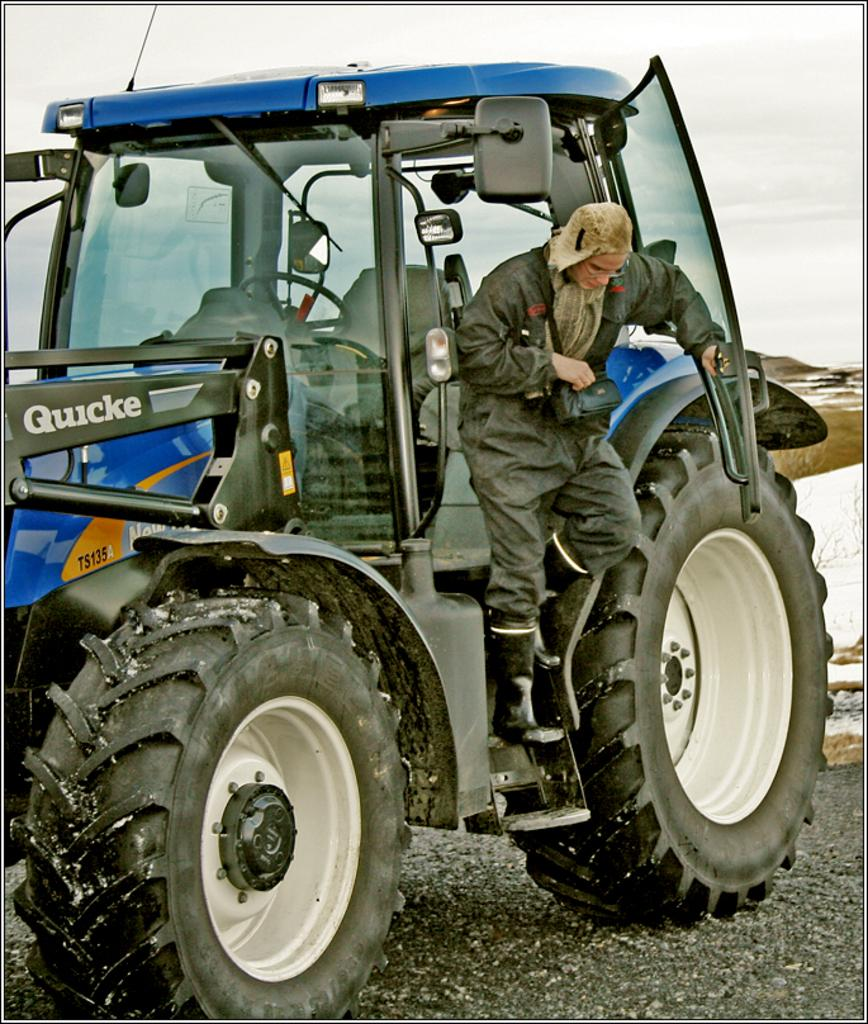What is the main subject of the image? There is a person on a vehicle in the image. Where is the vehicle located in the image? The vehicle is in the center of the image. What can be seen at the bottom of the image? There is a road visible at the bottom of the image. What type of texture can be seen on the bridge in the image? There is no bridge present in the image; it features a person on a vehicle and a road. 